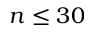Convert formula to latex. <formula><loc_0><loc_0><loc_500><loc_500>n \leq 3 0</formula> 